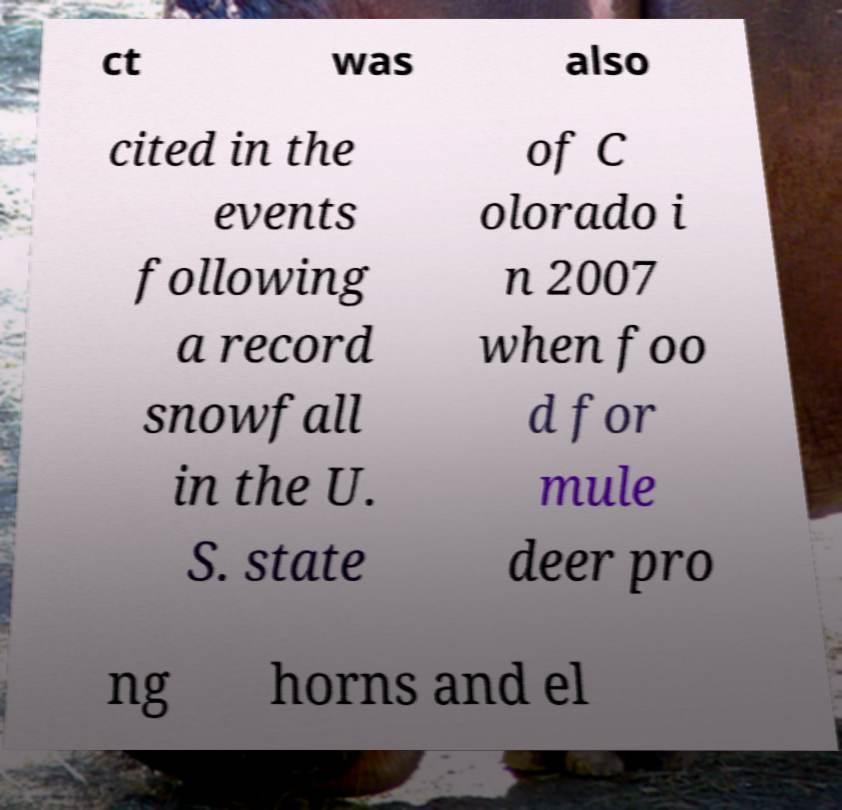Please identify and transcribe the text found in this image. ct was also cited in the events following a record snowfall in the U. S. state of C olorado i n 2007 when foo d for mule deer pro ng horns and el 